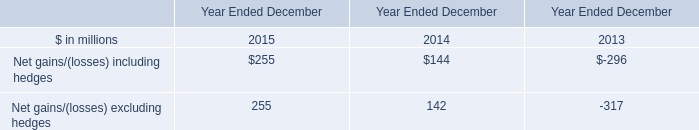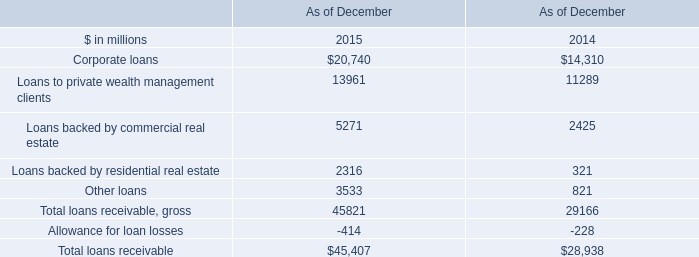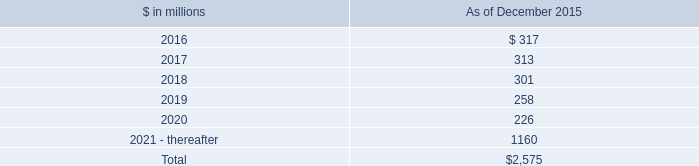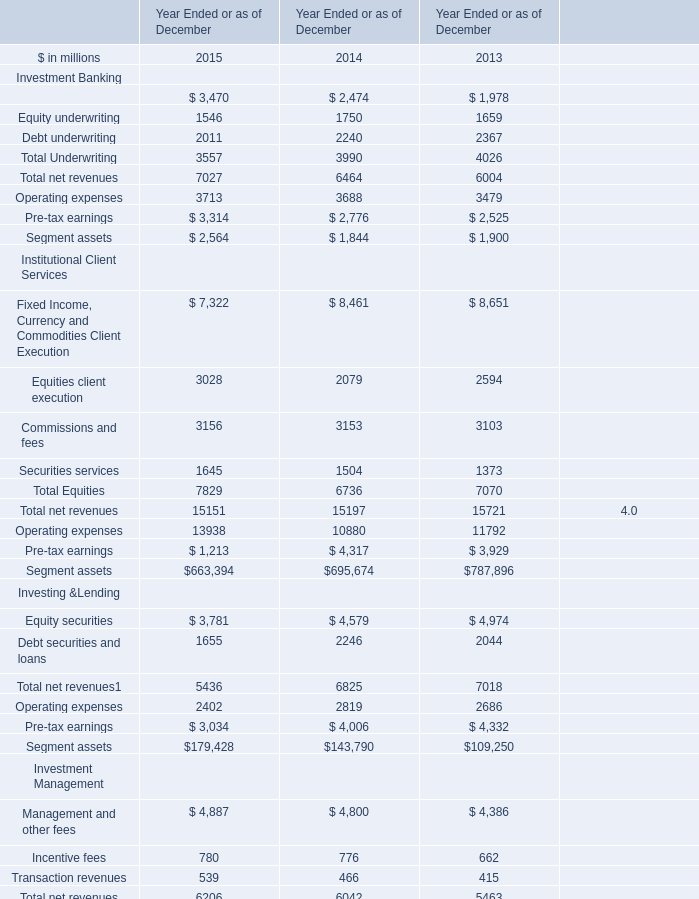what's the total amount of Other loans of As of December 2015, and Debt underwriting of Year Ended or as of December 2013 ? 
Computations: (3533.0 + 2367.0)
Answer: 5900.0. 